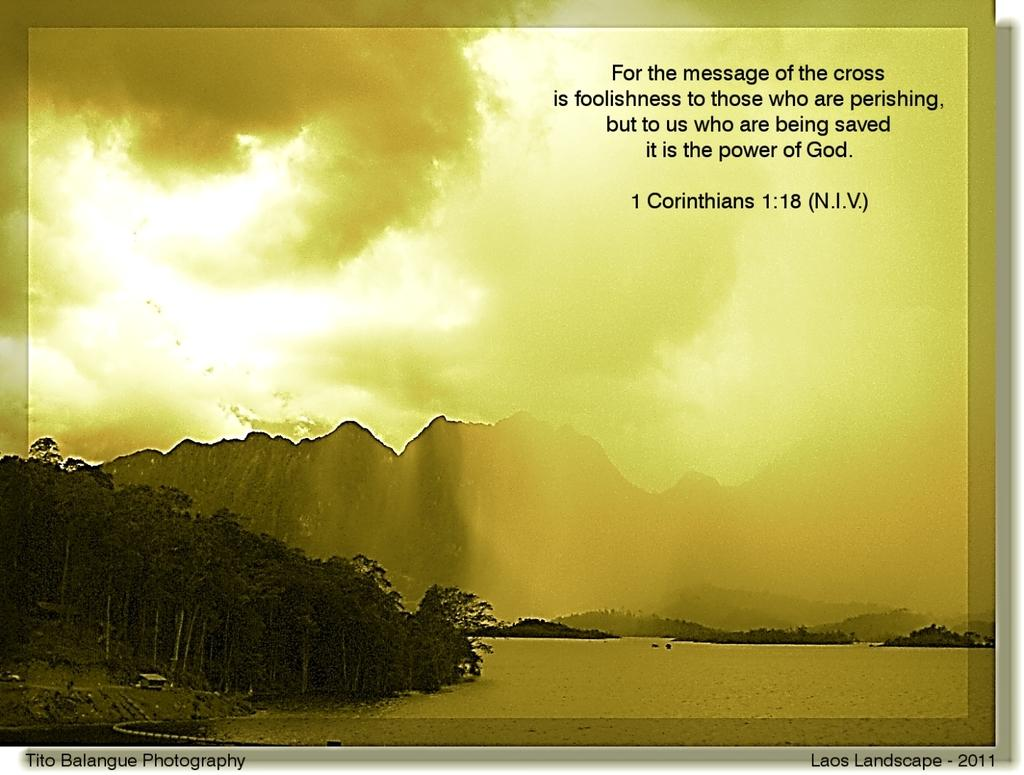<image>
Offer a succinct explanation of the picture presented. A picture of an island with mountains and a quote from 1 Corinthians. 